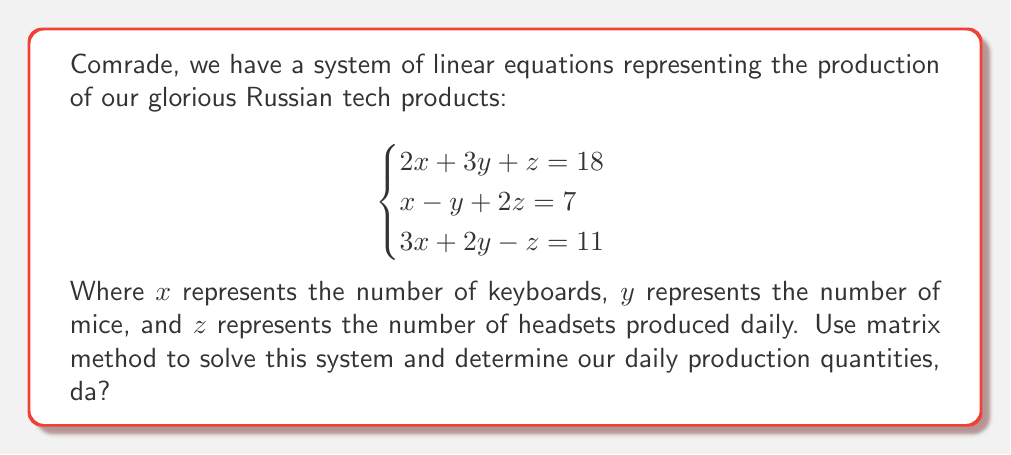Give your solution to this math problem. Ah, excellent question, tovarisch! Let us solve this problem step by step using the matrix method. It will be as smooth as our premium vodka!

Step 1: First, we write our system in matrix form $AX = B$:

$$\begin{bmatrix}
2 & 3 & 1 \\
1 & -1 & 2 \\
3 & 2 & -1
\end{bmatrix}
\begin{bmatrix}
x \\
y \\
z
\end{bmatrix} =
\begin{bmatrix}
18 \\
7 \\
11
\end{bmatrix}$$

Step 2: To solve for $X$, we need to find $A^{-1}$. Let's calculate the determinant of $A$ first:

$\det(A) = 2(-1-4) + 3(2+3) + 1(-1-6) = -10 + 15 - 7 = -2$

Step 3: Now, we find the adjugate matrix of $A$:

$$\text{adj}(A) = \begin{bmatrix}
(-1-4) & -(3+2) & (3-2) \\
-(2-3) & (2-3) & -(2-9) \\
(-1-6) & -(6-1) & (2-3)
\end{bmatrix} =
\begin{bmatrix}
-5 & -5 & 1 \\
1 & -1 & 7 \\
-7 & -5 & -1
\end{bmatrix}$$

Step 4: Calculate $A^{-1}$:

$$A^{-1} = -\frac{1}{2}\begin{bmatrix}
-5 & -5 & 1 \\
1 & -1 & 7 \\
-7 & -5 & -1
\end{bmatrix} =
\begin{bmatrix}
\frac{5}{2} & \frac{5}{2} & -\frac{1}{2} \\
-\frac{1}{2} & \frac{1}{2} & -\frac{7}{2} \\
\frac{7}{2} & \frac{5}{2} & \frac{1}{2}
\end{bmatrix}$$

Step 5: Now, we can solve for $X$:

$$X = A^{-1}B = \begin{bmatrix}
\frac{5}{2} & \frac{5}{2} & -\frac{1}{2} \\
-\frac{1}{2} & \frac{1}{2} & -\frac{7}{2} \\
\frac{7}{2} & \frac{5}{2} & \frac{1}{2}
\end{bmatrix}
\begin{bmatrix}
18 \\
7 \\
11
\end{bmatrix}$$

Step 6: Perform the matrix multiplication:

$$\begin{align}
x &= \frac{5}{2}(18) + \frac{5}{2}(7) - \frac{1}{2}(11) = 45 + \frac{35}{2} - \frac{11}{2} = 45 + 12 = 57 \\
y &= -\frac{1}{2}(18) + \frac{1}{2}(7) - \frac{7}{2}(11) = -9 + \frac{7}{2} - \frac{77}{2} = -9 - 35 = -44 \\
z &= \frac{7}{2}(18) + \frac{5}{2}(7) + \frac{1}{2}(11) = 63 + \frac{35}{2} + \frac{11}{2} = 63 + 23 = 86
\end{align}$$

And there we have it, comrade! Our glorious solution!
Answer: The solution to the system is:
$x = 57$, $y = -44$, and $z = 86$

This means we produce 57 keyboards, -44 mice (which is impossible, so we interpret as 0), and 86 headsets daily. 